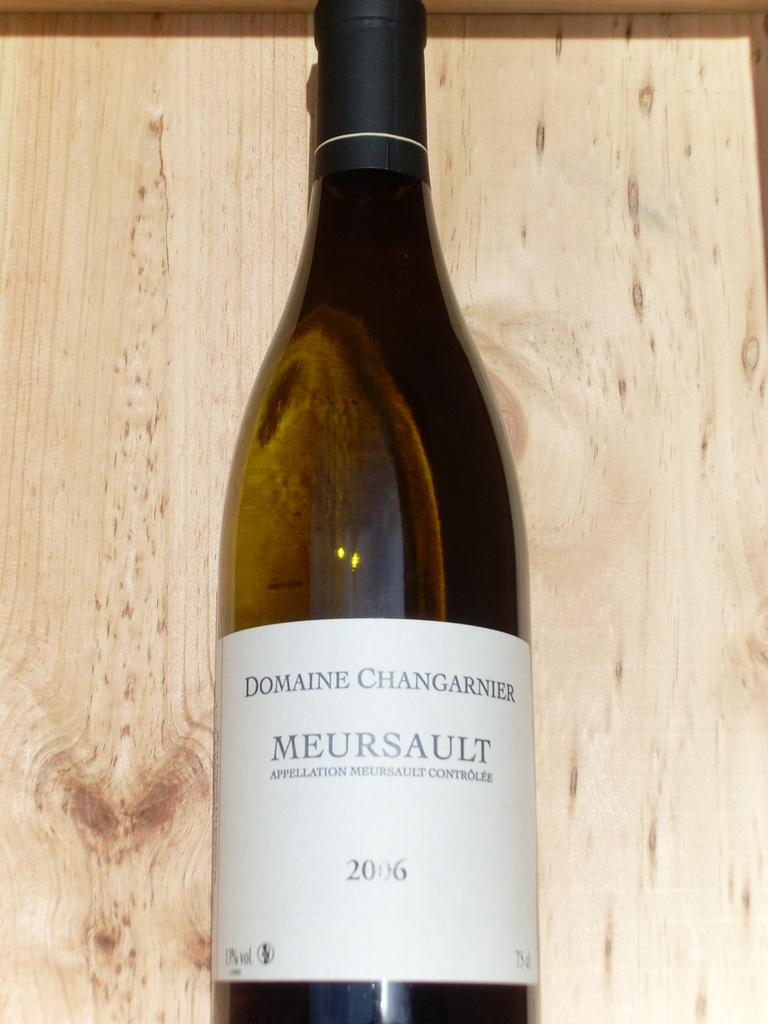<image>
Summarize the visual content of the image. A bottle of wine with Domaine Changarnier on the label. 